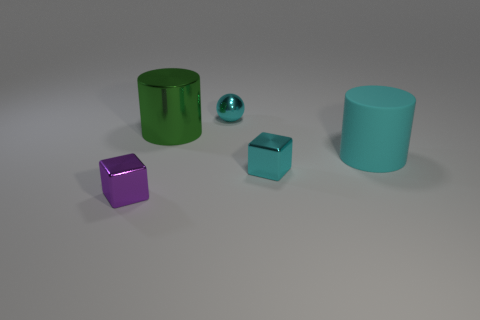There is a large cylinder that is the same color as the sphere; what is its material?
Provide a succinct answer. Rubber. Does the cyan cylinder have the same size as the purple metallic thing left of the rubber cylinder?
Keep it short and to the point. No. How many other objects are there of the same material as the large cyan thing?
Keep it short and to the point. 0. How many things are large green shiny objects to the right of the tiny purple thing or metal objects in front of the big green thing?
Offer a terse response. 3. There is another big thing that is the same shape as the green shiny object; what is it made of?
Your answer should be compact. Rubber. Is there a red cube?
Keep it short and to the point. No. What is the size of the thing that is both in front of the large cyan thing and to the right of the purple object?
Provide a short and direct response. Small. What is the shape of the small purple object?
Your answer should be very brief. Cube. There is a small block behind the tiny purple metal object; is there a shiny cylinder in front of it?
Your response must be concise. No. There is a sphere that is the same size as the purple metal block; what material is it?
Give a very brief answer. Metal. 